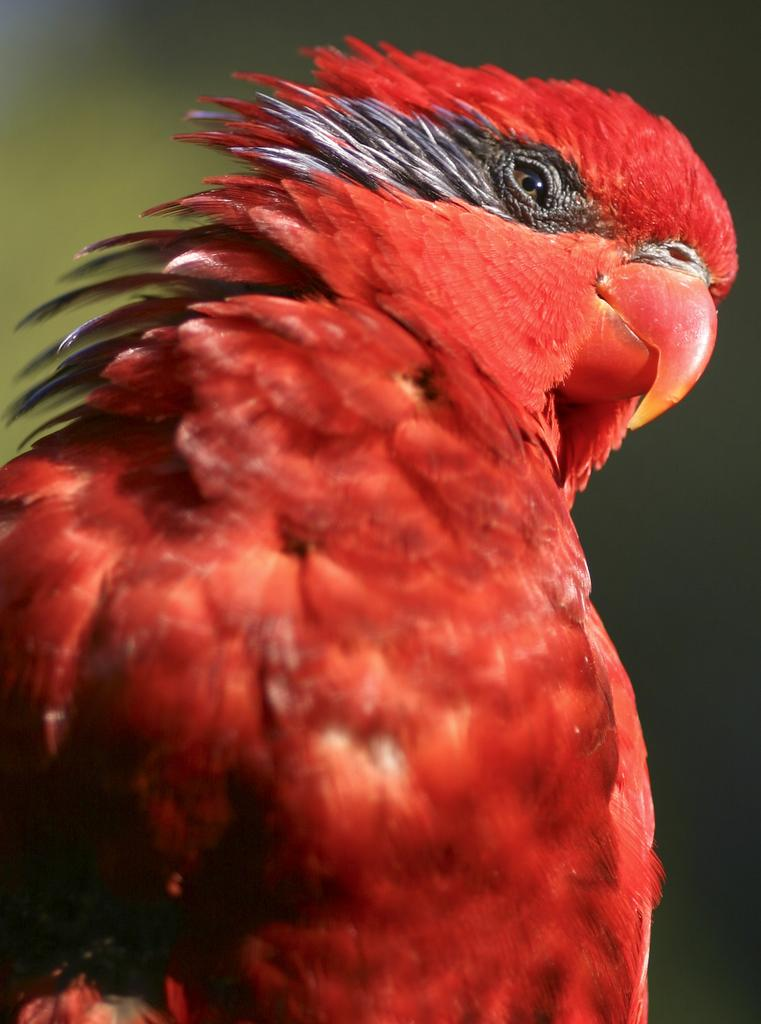What type of animal is present in the image? There is a bird in the image. What color is the bird? The bird is red in color. What can be seen in the background behind the bird? The background of the bird is blue. How many straws are being used to measure the height of the tree in the image? There is no tree or straws present in the image. 